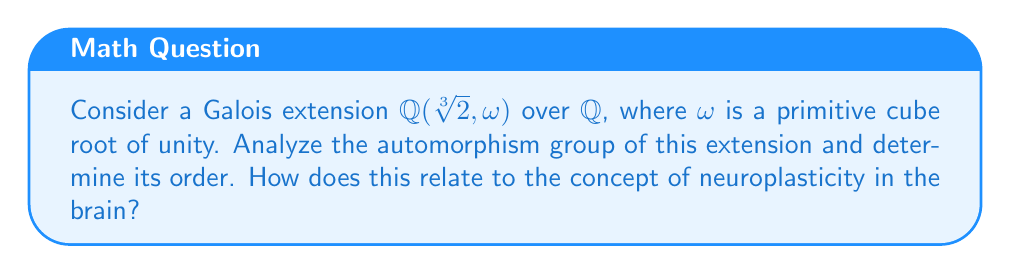Provide a solution to this math problem. Let's approach this step-by-step:

1) First, we need to understand the structure of the field extension:
   $\mathbb{Q}(\sqrt[3]{2}, \omega)$ is the splitting field of $x^3 - 2$ over $\mathbb{Q}$.

2) The degree of this extension is:
   $[\mathbb{Q}(\sqrt[3]{2}, \omega) : \mathbb{Q}] = 6$

3) The automorphism group of a Galois extension is isomorphic to the Galois group. In this case, it's isomorphic to $S_3$, the symmetric group on 3 elements.

4) To see why, consider the possible automorphisms:
   - Identity: fixes everything
   - $\sigma$: sends $\sqrt[3]{2}$ to $\omega\sqrt[3]{2}$
   - $\sigma^2$: sends $\sqrt[3]{2}$ to $\omega^2\sqrt[3]{2}$
   - $\tau$: fixes $\sqrt[3]{2}$, swaps $\omega$ and $\omega^2$
   - $\sigma\tau$: combines effects of $\sigma$ and $\tau$
   - $\sigma^2\tau$: combines effects of $\sigma^2$ and $\tau$

5) These 6 automorphisms form a group isomorphic to $S_3$.

6) The order of $S_3$ is 6, which matches the degree of the extension.

7) Relating to neuroplasticity: Just as the automorphism group represents the symmetries of the field extension, neuroplasticity represents the brain's ability to reorganize itself. The order of the automorphism group (6) could be analogous to the brain's capacity for forming new neural connections, highlighting the complexity and adaptability of both mathematical structures and neural networks.
Answer: $S_3$, order 6 